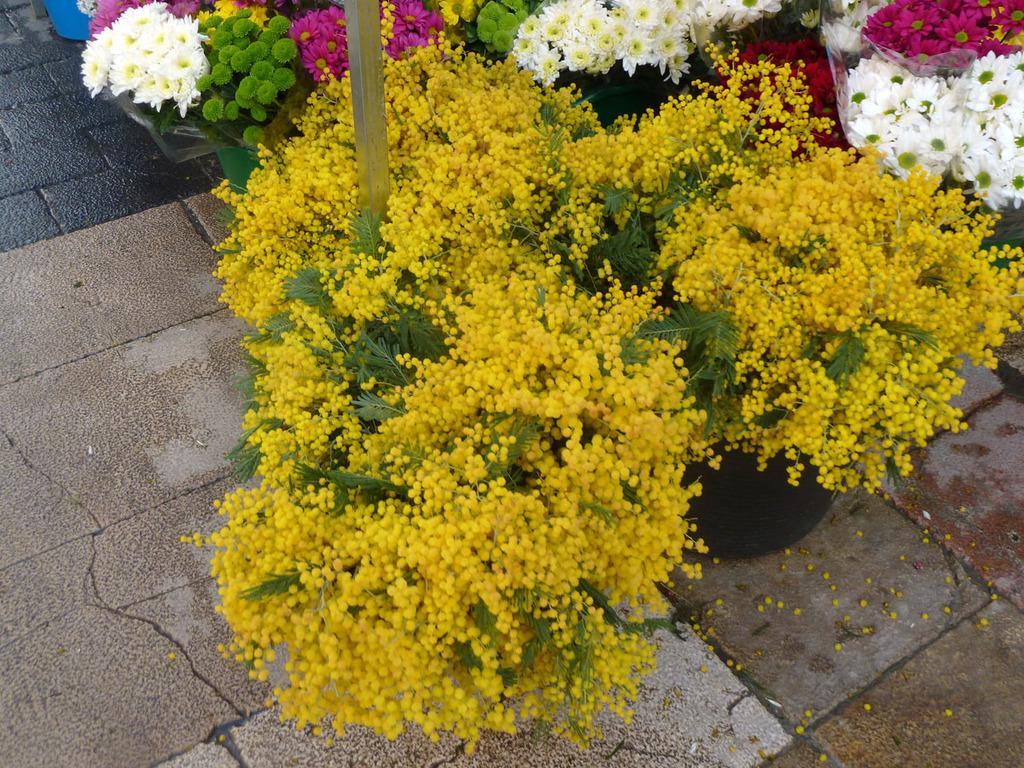How would you summarize this image in a sentence or two? We can see flowers, plants,pole and floor. 